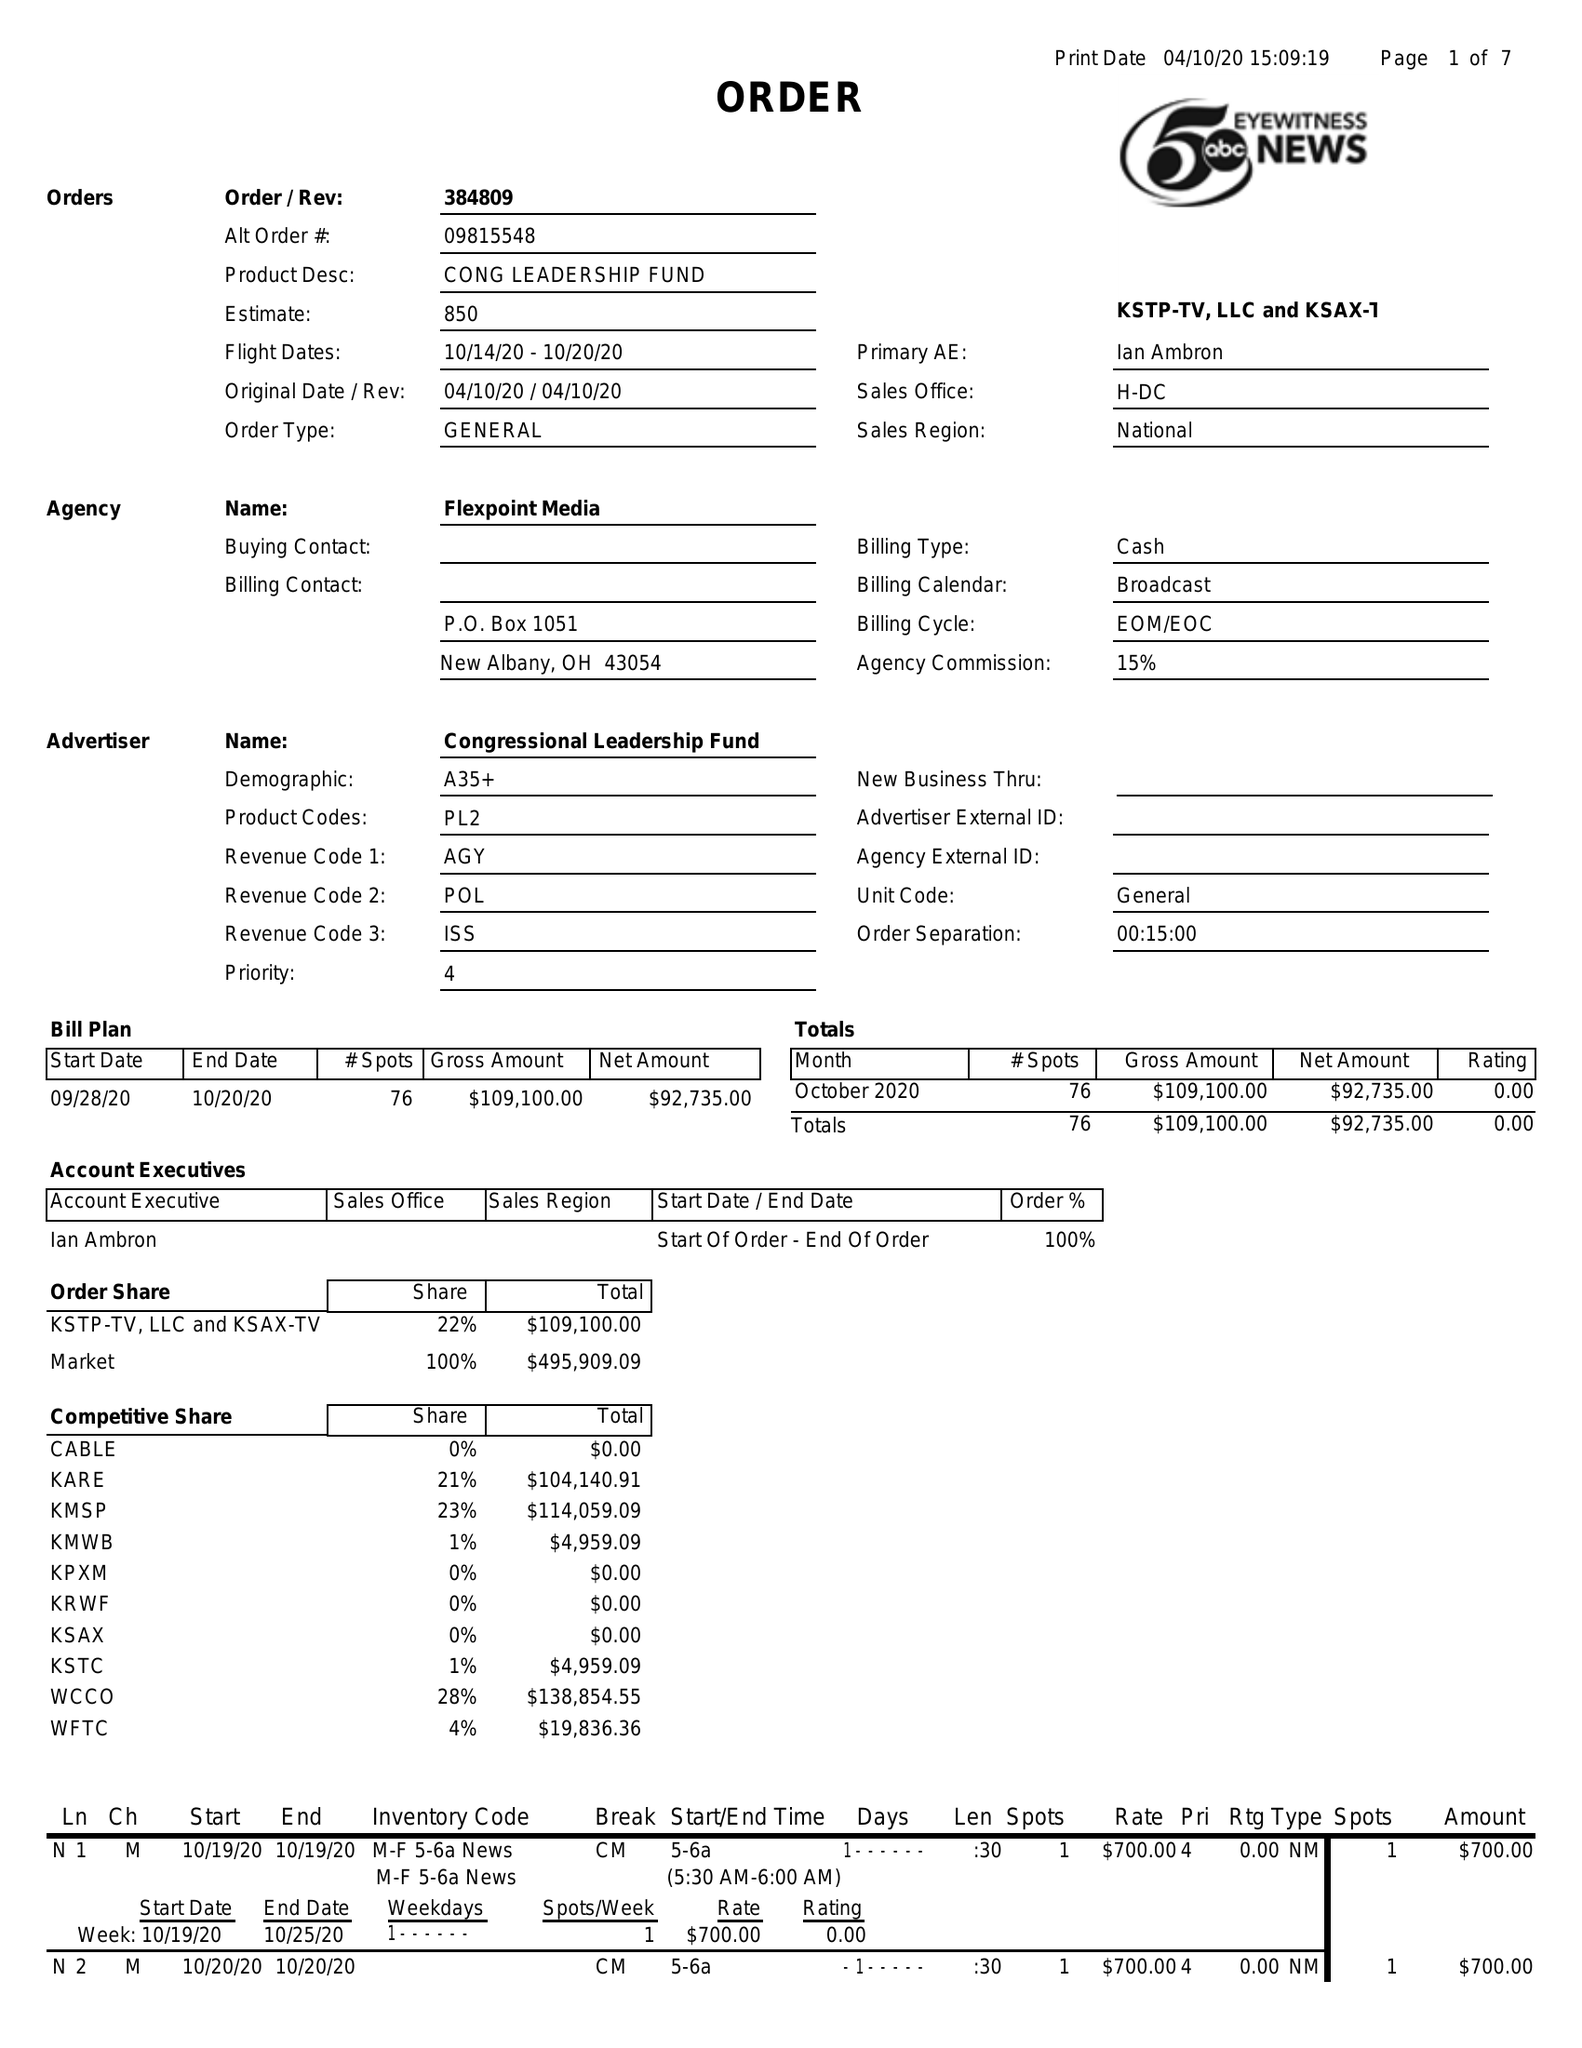What is the value for the flight_from?
Answer the question using a single word or phrase. 10/14/20 